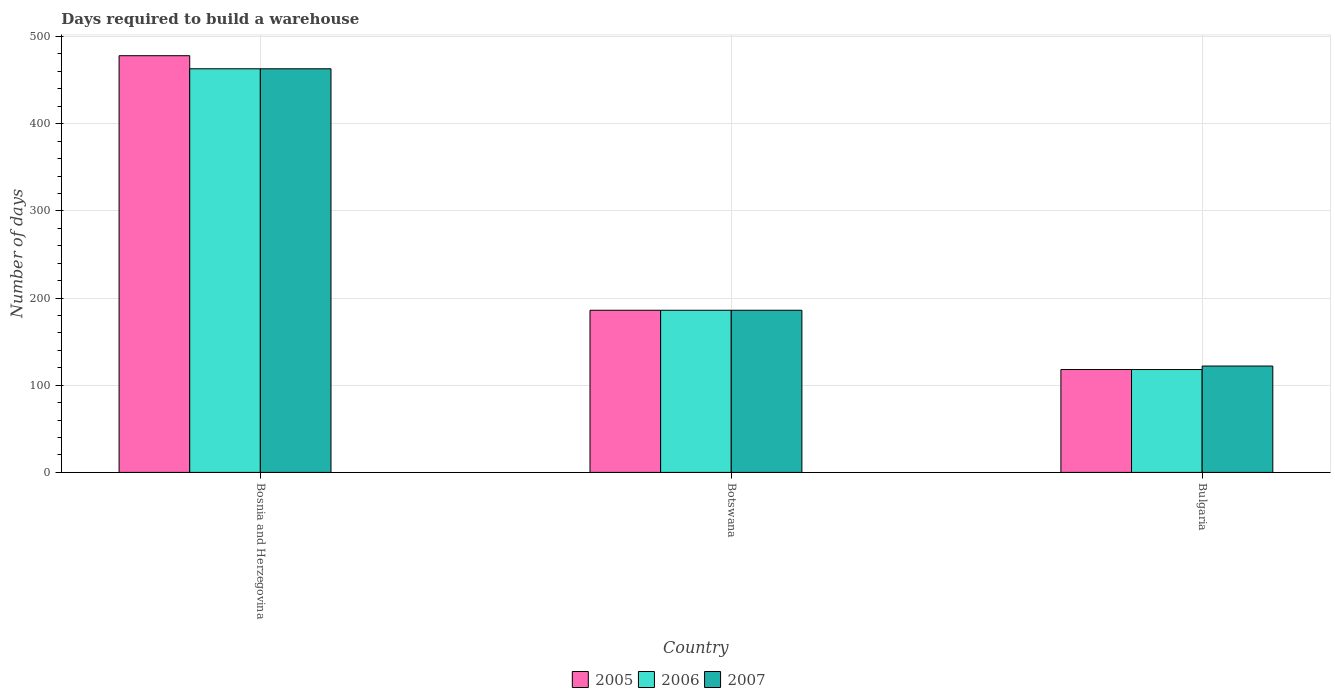Are the number of bars per tick equal to the number of legend labels?
Give a very brief answer. Yes. How many bars are there on the 3rd tick from the right?
Keep it short and to the point. 3. What is the label of the 1st group of bars from the left?
Provide a short and direct response. Bosnia and Herzegovina. What is the days required to build a warehouse in in 2007 in Bulgaria?
Your answer should be very brief. 122. Across all countries, what is the maximum days required to build a warehouse in in 2007?
Offer a terse response. 463. Across all countries, what is the minimum days required to build a warehouse in in 2007?
Give a very brief answer. 122. In which country was the days required to build a warehouse in in 2007 maximum?
Offer a terse response. Bosnia and Herzegovina. In which country was the days required to build a warehouse in in 2005 minimum?
Your answer should be compact. Bulgaria. What is the total days required to build a warehouse in in 2005 in the graph?
Provide a succinct answer. 782. What is the difference between the days required to build a warehouse in in 2005 in Bosnia and Herzegovina and that in Bulgaria?
Keep it short and to the point. 360. What is the average days required to build a warehouse in in 2006 per country?
Offer a terse response. 255.67. In how many countries, is the days required to build a warehouse in in 2006 greater than 180 days?
Your response must be concise. 2. What is the ratio of the days required to build a warehouse in in 2006 in Bosnia and Herzegovina to that in Botswana?
Make the answer very short. 2.49. Is the days required to build a warehouse in in 2007 in Bosnia and Herzegovina less than that in Bulgaria?
Your response must be concise. No. What is the difference between the highest and the lowest days required to build a warehouse in in 2005?
Give a very brief answer. 360. In how many countries, is the days required to build a warehouse in in 2005 greater than the average days required to build a warehouse in in 2005 taken over all countries?
Offer a very short reply. 1. Are all the bars in the graph horizontal?
Ensure brevity in your answer.  No. How many countries are there in the graph?
Ensure brevity in your answer.  3. What is the difference between two consecutive major ticks on the Y-axis?
Offer a very short reply. 100. Are the values on the major ticks of Y-axis written in scientific E-notation?
Your response must be concise. No. Does the graph contain grids?
Offer a terse response. Yes. Where does the legend appear in the graph?
Ensure brevity in your answer.  Bottom center. How are the legend labels stacked?
Offer a very short reply. Horizontal. What is the title of the graph?
Offer a terse response. Days required to build a warehouse. Does "2002" appear as one of the legend labels in the graph?
Your answer should be compact. No. What is the label or title of the X-axis?
Provide a short and direct response. Country. What is the label or title of the Y-axis?
Your answer should be compact. Number of days. What is the Number of days of 2005 in Bosnia and Herzegovina?
Offer a terse response. 478. What is the Number of days of 2006 in Bosnia and Herzegovina?
Make the answer very short. 463. What is the Number of days of 2007 in Bosnia and Herzegovina?
Make the answer very short. 463. What is the Number of days in 2005 in Botswana?
Offer a very short reply. 186. What is the Number of days in 2006 in Botswana?
Make the answer very short. 186. What is the Number of days of 2007 in Botswana?
Keep it short and to the point. 186. What is the Number of days of 2005 in Bulgaria?
Provide a short and direct response. 118. What is the Number of days in 2006 in Bulgaria?
Make the answer very short. 118. What is the Number of days of 2007 in Bulgaria?
Make the answer very short. 122. Across all countries, what is the maximum Number of days in 2005?
Offer a very short reply. 478. Across all countries, what is the maximum Number of days in 2006?
Your response must be concise. 463. Across all countries, what is the maximum Number of days of 2007?
Your answer should be compact. 463. Across all countries, what is the minimum Number of days of 2005?
Make the answer very short. 118. Across all countries, what is the minimum Number of days of 2006?
Provide a short and direct response. 118. Across all countries, what is the minimum Number of days in 2007?
Ensure brevity in your answer.  122. What is the total Number of days of 2005 in the graph?
Offer a very short reply. 782. What is the total Number of days of 2006 in the graph?
Offer a very short reply. 767. What is the total Number of days in 2007 in the graph?
Offer a very short reply. 771. What is the difference between the Number of days in 2005 in Bosnia and Herzegovina and that in Botswana?
Ensure brevity in your answer.  292. What is the difference between the Number of days of 2006 in Bosnia and Herzegovina and that in Botswana?
Offer a terse response. 277. What is the difference between the Number of days in 2007 in Bosnia and Herzegovina and that in Botswana?
Offer a very short reply. 277. What is the difference between the Number of days of 2005 in Bosnia and Herzegovina and that in Bulgaria?
Your answer should be compact. 360. What is the difference between the Number of days in 2006 in Bosnia and Herzegovina and that in Bulgaria?
Make the answer very short. 345. What is the difference between the Number of days of 2007 in Bosnia and Herzegovina and that in Bulgaria?
Offer a very short reply. 341. What is the difference between the Number of days in 2005 in Botswana and that in Bulgaria?
Your answer should be very brief. 68. What is the difference between the Number of days in 2005 in Bosnia and Herzegovina and the Number of days in 2006 in Botswana?
Offer a terse response. 292. What is the difference between the Number of days in 2005 in Bosnia and Herzegovina and the Number of days in 2007 in Botswana?
Offer a terse response. 292. What is the difference between the Number of days in 2006 in Bosnia and Herzegovina and the Number of days in 2007 in Botswana?
Offer a terse response. 277. What is the difference between the Number of days in 2005 in Bosnia and Herzegovina and the Number of days in 2006 in Bulgaria?
Your response must be concise. 360. What is the difference between the Number of days of 2005 in Bosnia and Herzegovina and the Number of days of 2007 in Bulgaria?
Keep it short and to the point. 356. What is the difference between the Number of days of 2006 in Bosnia and Herzegovina and the Number of days of 2007 in Bulgaria?
Give a very brief answer. 341. What is the difference between the Number of days of 2006 in Botswana and the Number of days of 2007 in Bulgaria?
Make the answer very short. 64. What is the average Number of days in 2005 per country?
Provide a short and direct response. 260.67. What is the average Number of days in 2006 per country?
Keep it short and to the point. 255.67. What is the average Number of days in 2007 per country?
Your answer should be very brief. 257. What is the difference between the Number of days in 2006 and Number of days in 2007 in Bosnia and Herzegovina?
Your answer should be compact. 0. What is the difference between the Number of days of 2006 and Number of days of 2007 in Botswana?
Provide a succinct answer. 0. What is the difference between the Number of days of 2006 and Number of days of 2007 in Bulgaria?
Your answer should be compact. -4. What is the ratio of the Number of days of 2005 in Bosnia and Herzegovina to that in Botswana?
Your answer should be very brief. 2.57. What is the ratio of the Number of days in 2006 in Bosnia and Herzegovina to that in Botswana?
Provide a short and direct response. 2.49. What is the ratio of the Number of days of 2007 in Bosnia and Herzegovina to that in Botswana?
Offer a terse response. 2.49. What is the ratio of the Number of days of 2005 in Bosnia and Herzegovina to that in Bulgaria?
Keep it short and to the point. 4.05. What is the ratio of the Number of days in 2006 in Bosnia and Herzegovina to that in Bulgaria?
Ensure brevity in your answer.  3.92. What is the ratio of the Number of days in 2007 in Bosnia and Herzegovina to that in Bulgaria?
Your answer should be compact. 3.8. What is the ratio of the Number of days in 2005 in Botswana to that in Bulgaria?
Your answer should be very brief. 1.58. What is the ratio of the Number of days of 2006 in Botswana to that in Bulgaria?
Your response must be concise. 1.58. What is the ratio of the Number of days in 2007 in Botswana to that in Bulgaria?
Give a very brief answer. 1.52. What is the difference between the highest and the second highest Number of days in 2005?
Your answer should be compact. 292. What is the difference between the highest and the second highest Number of days of 2006?
Keep it short and to the point. 277. What is the difference between the highest and the second highest Number of days of 2007?
Provide a succinct answer. 277. What is the difference between the highest and the lowest Number of days in 2005?
Your answer should be compact. 360. What is the difference between the highest and the lowest Number of days of 2006?
Offer a very short reply. 345. What is the difference between the highest and the lowest Number of days in 2007?
Your response must be concise. 341. 